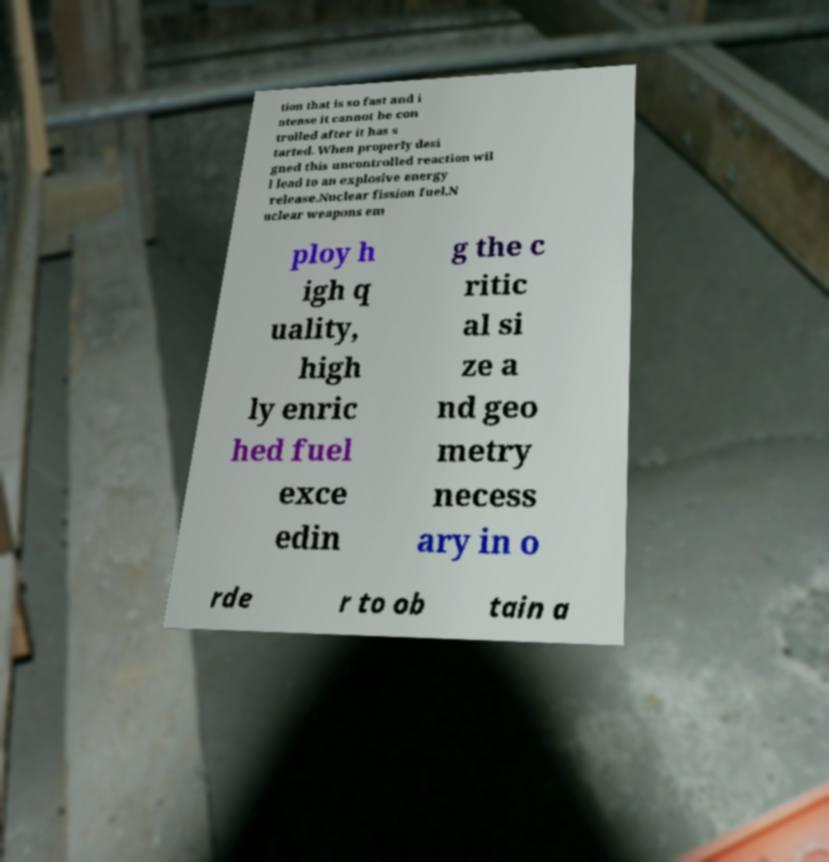Please read and relay the text visible in this image. What does it say? tion that is so fast and i ntense it cannot be con trolled after it has s tarted. When properly desi gned this uncontrolled reaction wil l lead to an explosive energy release.Nuclear fission fuel.N uclear weapons em ploy h igh q uality, high ly enric hed fuel exce edin g the c ritic al si ze a nd geo metry necess ary in o rde r to ob tain a 